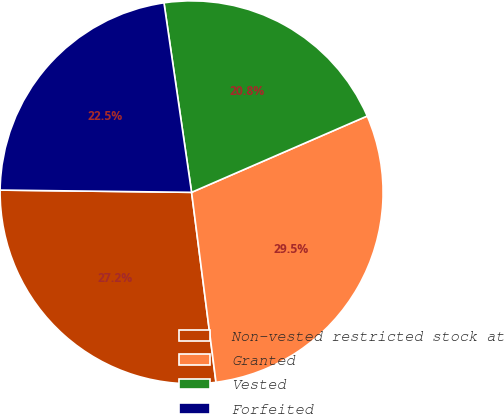Convert chart. <chart><loc_0><loc_0><loc_500><loc_500><pie_chart><fcel>Non-vested restricted stock at<fcel>Granted<fcel>Vested<fcel>Forfeited<nl><fcel>27.22%<fcel>29.49%<fcel>20.78%<fcel>22.51%<nl></chart> 